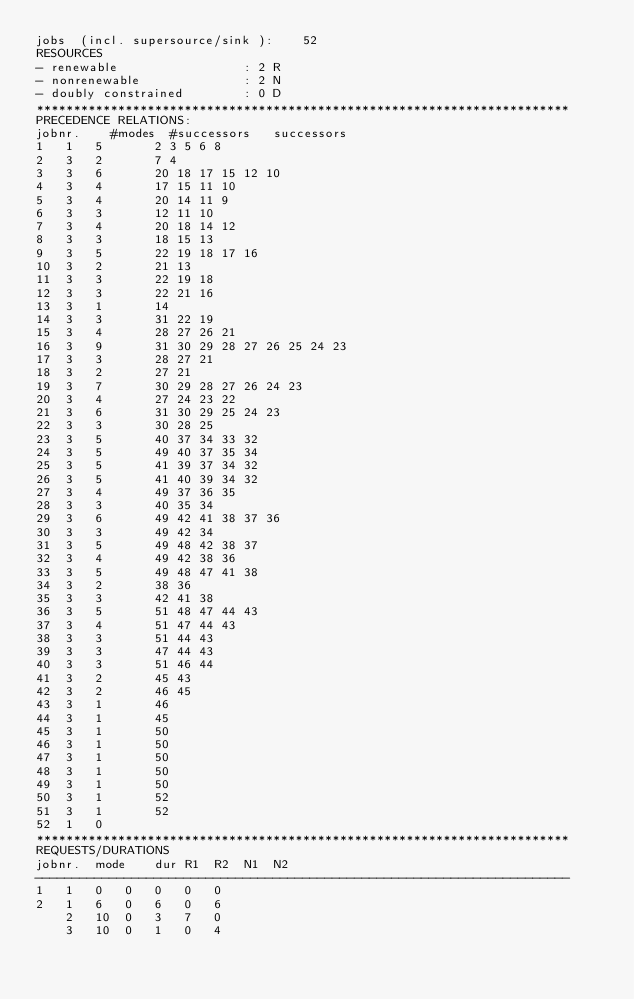Convert code to text. <code><loc_0><loc_0><loc_500><loc_500><_ObjectiveC_>jobs  (incl. supersource/sink ):	52
RESOURCES
- renewable                 : 2 R
- nonrenewable              : 2 N
- doubly constrained        : 0 D
************************************************************************
PRECEDENCE RELATIONS:
jobnr.    #modes  #successors   successors
1	1	5		2 3 5 6 8 
2	3	2		7 4 
3	3	6		20 18 17 15 12 10 
4	3	4		17 15 11 10 
5	3	4		20 14 11 9 
6	3	3		12 11 10 
7	3	4		20 18 14 12 
8	3	3		18 15 13 
9	3	5		22 19 18 17 16 
10	3	2		21 13 
11	3	3		22 19 18 
12	3	3		22 21 16 
13	3	1		14 
14	3	3		31 22 19 
15	3	4		28 27 26 21 
16	3	9		31 30 29 28 27 26 25 24 23 
17	3	3		28 27 21 
18	3	2		27 21 
19	3	7		30 29 28 27 26 24 23 
20	3	4		27 24 23 22 
21	3	6		31 30 29 25 24 23 
22	3	3		30 28 25 
23	3	5		40 37 34 33 32 
24	3	5		49 40 37 35 34 
25	3	5		41 39 37 34 32 
26	3	5		41 40 39 34 32 
27	3	4		49 37 36 35 
28	3	3		40 35 34 
29	3	6		49 42 41 38 37 36 
30	3	3		49 42 34 
31	3	5		49 48 42 38 37 
32	3	4		49 42 38 36 
33	3	5		49 48 47 41 38 
34	3	2		38 36 
35	3	3		42 41 38 
36	3	5		51 48 47 44 43 
37	3	4		51 47 44 43 
38	3	3		51 44 43 
39	3	3		47 44 43 
40	3	3		51 46 44 
41	3	2		45 43 
42	3	2		46 45 
43	3	1		46 
44	3	1		45 
45	3	1		50 
46	3	1		50 
47	3	1		50 
48	3	1		50 
49	3	1		50 
50	3	1		52 
51	3	1		52 
52	1	0		
************************************************************************
REQUESTS/DURATIONS
jobnr.	mode	dur	R1	R2	N1	N2	
------------------------------------------------------------------------
1	1	0	0	0	0	0	
2	1	6	0	6	0	6	
	2	10	0	3	7	0	
	3	10	0	1	0	4	</code> 